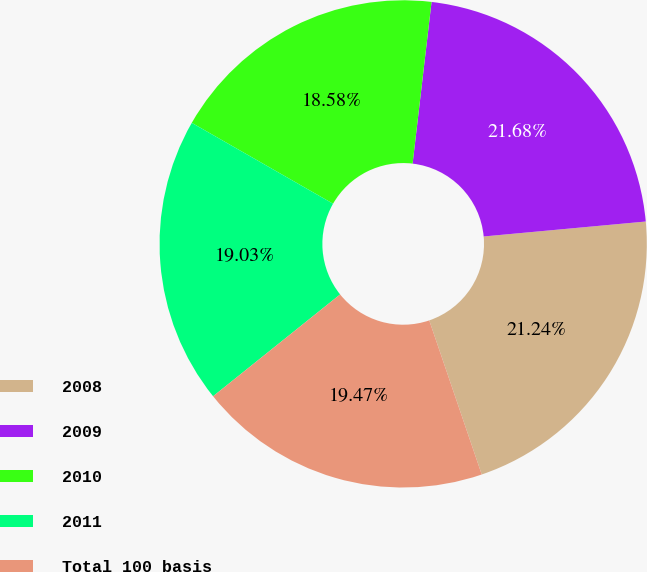Convert chart to OTSL. <chart><loc_0><loc_0><loc_500><loc_500><pie_chart><fcel>2008<fcel>2009<fcel>2010<fcel>2011<fcel>Total 100 basis<nl><fcel>21.24%<fcel>21.68%<fcel>18.58%<fcel>19.03%<fcel>19.47%<nl></chart> 